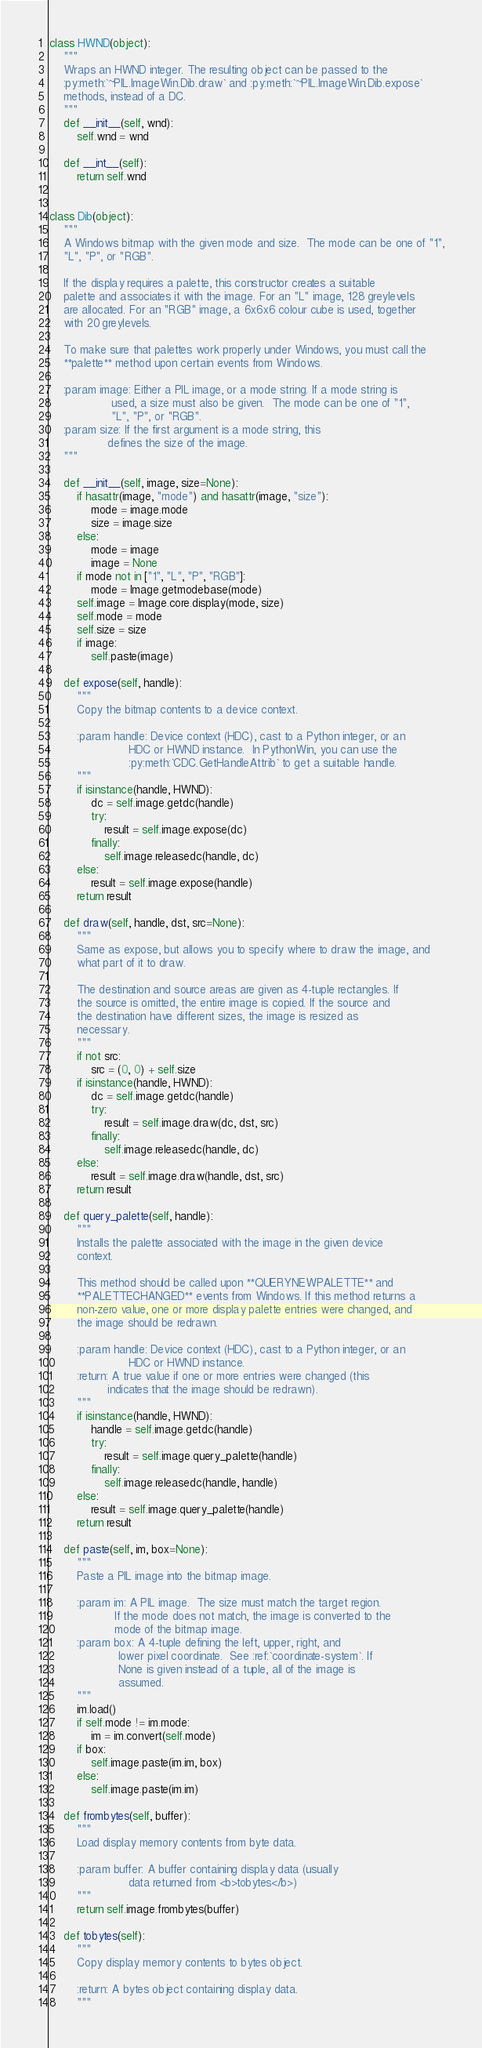<code> <loc_0><loc_0><loc_500><loc_500><_Python_>
class HWND(object):
    """
    Wraps an HWND integer. The resulting object can be passed to the
    :py:meth:`~PIL.ImageWin.Dib.draw` and :py:meth:`~PIL.ImageWin.Dib.expose`
    methods, instead of a DC.
    """
    def __init__(self, wnd):
        self.wnd = wnd

    def __int__(self):
        return self.wnd


class Dib(object):
    """
    A Windows bitmap with the given mode and size.  The mode can be one of "1",
    "L", "P", or "RGB".

    If the display requires a palette, this constructor creates a suitable
    palette and associates it with the image. For an "L" image, 128 greylevels
    are allocated. For an "RGB" image, a 6x6x6 colour cube is used, together
    with 20 greylevels.

    To make sure that palettes work properly under Windows, you must call the
    **palette** method upon certain events from Windows.

    :param image: Either a PIL image, or a mode string. If a mode string is
                  used, a size must also be given.  The mode can be one of "1",
                  "L", "P", or "RGB".
    :param size: If the first argument is a mode string, this
                 defines the size of the image.
    """

    def __init__(self, image, size=None):
        if hasattr(image, "mode") and hasattr(image, "size"):
            mode = image.mode
            size = image.size
        else:
            mode = image
            image = None
        if mode not in ["1", "L", "P", "RGB"]:
            mode = Image.getmodebase(mode)
        self.image = Image.core.display(mode, size)
        self.mode = mode
        self.size = size
        if image:
            self.paste(image)

    def expose(self, handle):
        """
        Copy the bitmap contents to a device context.

        :param handle: Device context (HDC), cast to a Python integer, or an
                       HDC or HWND instance.  In PythonWin, you can use the
                       :py:meth:`CDC.GetHandleAttrib` to get a suitable handle.
        """
        if isinstance(handle, HWND):
            dc = self.image.getdc(handle)
            try:
                result = self.image.expose(dc)
            finally:
                self.image.releasedc(handle, dc)
        else:
            result = self.image.expose(handle)
        return result

    def draw(self, handle, dst, src=None):
        """
        Same as expose, but allows you to specify where to draw the image, and
        what part of it to draw.

        The destination and source areas are given as 4-tuple rectangles. If
        the source is omitted, the entire image is copied. If the source and
        the destination have different sizes, the image is resized as
        necessary.
        """
        if not src:
            src = (0, 0) + self.size
        if isinstance(handle, HWND):
            dc = self.image.getdc(handle)
            try:
                result = self.image.draw(dc, dst, src)
            finally:
                self.image.releasedc(handle, dc)
        else:
            result = self.image.draw(handle, dst, src)
        return result

    def query_palette(self, handle):
        """
        Installs the palette associated with the image in the given device
        context.

        This method should be called upon **QUERYNEWPALETTE** and
        **PALETTECHANGED** events from Windows. If this method returns a
        non-zero value, one or more display palette entries were changed, and
        the image should be redrawn.

        :param handle: Device context (HDC), cast to a Python integer, or an
                       HDC or HWND instance.
        :return: A true value if one or more entries were changed (this
                 indicates that the image should be redrawn).
        """
        if isinstance(handle, HWND):
            handle = self.image.getdc(handle)
            try:
                result = self.image.query_palette(handle)
            finally:
                self.image.releasedc(handle, handle)
        else:
            result = self.image.query_palette(handle)
        return result

    def paste(self, im, box=None):
        """
        Paste a PIL image into the bitmap image.

        :param im: A PIL image.  The size must match the target region.
                   If the mode does not match, the image is converted to the
                   mode of the bitmap image.
        :param box: A 4-tuple defining the left, upper, right, and
                    lower pixel coordinate.  See :ref:`coordinate-system`. If
                    None is given instead of a tuple, all of the image is
                    assumed.
        """
        im.load()
        if self.mode != im.mode:
            im = im.convert(self.mode)
        if box:
            self.image.paste(im.im, box)
        else:
            self.image.paste(im.im)

    def frombytes(self, buffer):
        """
        Load display memory contents from byte data.

        :param buffer: A buffer containing display data (usually
                       data returned from <b>tobytes</b>)
        """
        return self.image.frombytes(buffer)

    def tobytes(self):
        """
        Copy display memory contents to bytes object.

        :return: A bytes object containing display data.
        """</code> 